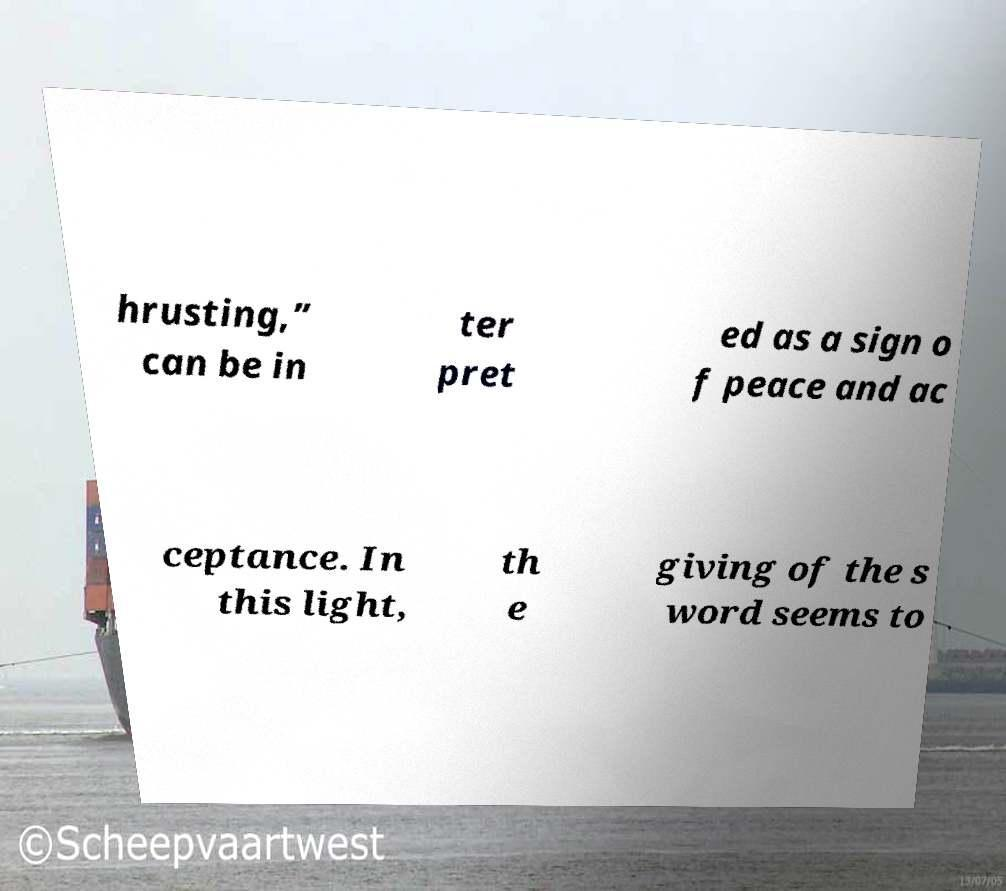Can you accurately transcribe the text from the provided image for me? hrusting,” can be in ter pret ed as a sign o f peace and ac ceptance. In this light, th e giving of the s word seems to 